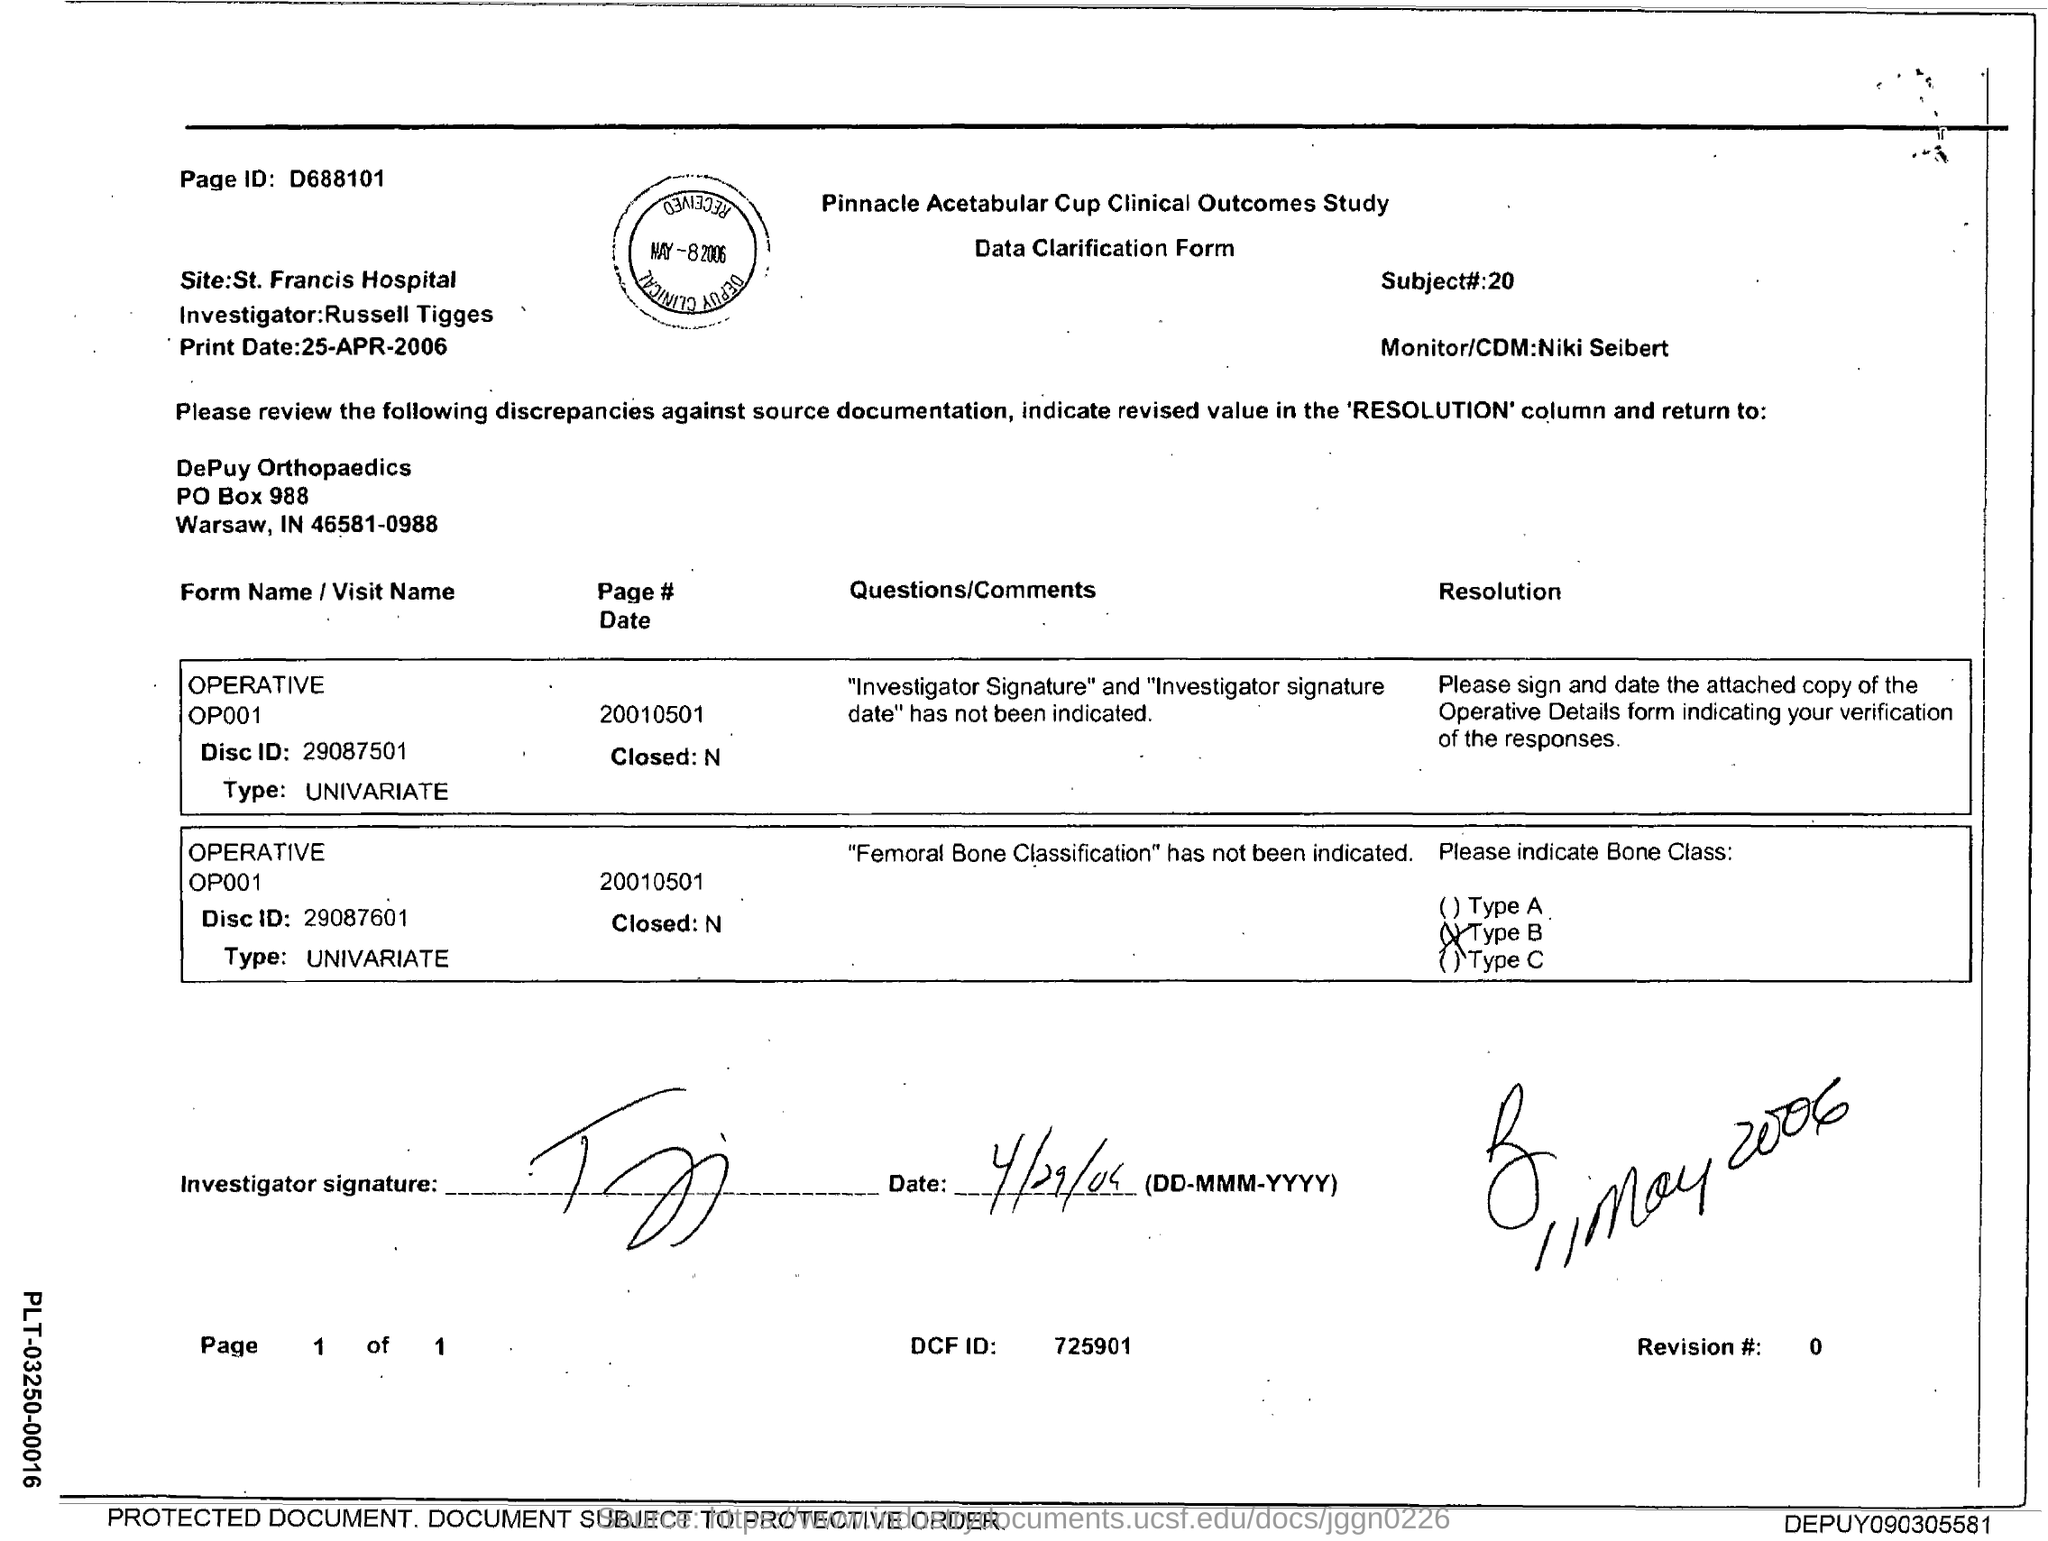Mention a couple of crucial points in this snapshot. The page ID located at the top left corner is D688101. 